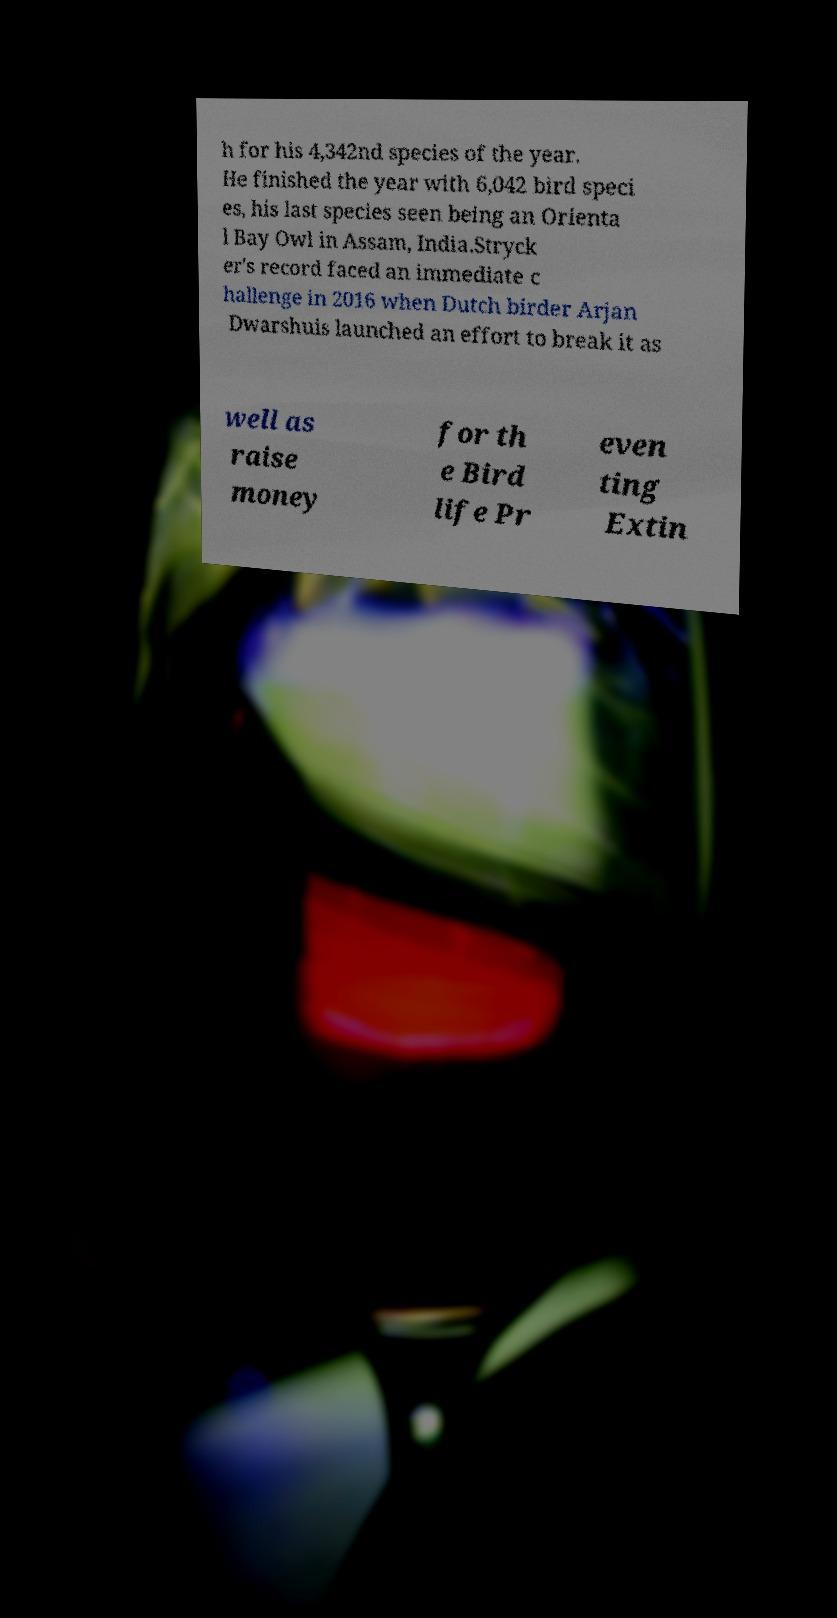What messages or text are displayed in this image? I need them in a readable, typed format. h for his 4,342nd species of the year. He finished the year with 6,042 bird speci es, his last species seen being an Orienta l Bay Owl in Assam, India.Stryck er's record faced an immediate c hallenge in 2016 when Dutch birder Arjan Dwarshuis launched an effort to break it as well as raise money for th e Bird life Pr even ting Extin 